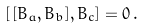<formula> <loc_0><loc_0><loc_500><loc_500>[ \, [ B _ { a } , B _ { b } ] , B _ { c } ] = 0 \, .</formula> 